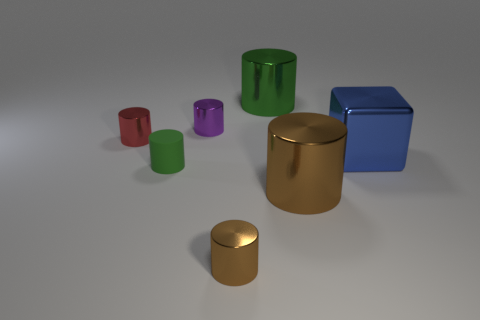How many blue shiny objects have the same shape as the large brown object?
Your response must be concise. 0. What number of things are big shiny cylinders that are in front of the tiny green matte cylinder or small brown cylinders in front of the blue block?
Provide a succinct answer. 2. The green cylinder that is in front of the large cylinder behind the green object left of the tiny brown metallic object is made of what material?
Make the answer very short. Rubber. There is a tiny thing in front of the big brown metallic object; is it the same color as the matte cylinder?
Provide a short and direct response. No. There is a tiny cylinder that is both in front of the small red metallic object and left of the tiny brown shiny cylinder; what is it made of?
Make the answer very short. Rubber. Is there a green metal block that has the same size as the green matte cylinder?
Your answer should be compact. No. What number of tiny shiny objects are there?
Your answer should be compact. 3. There is a cube; what number of small red things are behind it?
Keep it short and to the point. 1. Do the large brown object and the tiny red cylinder have the same material?
Ensure brevity in your answer.  Yes. How many metal things are both in front of the tiny red shiny cylinder and behind the tiny brown thing?
Ensure brevity in your answer.  2. 